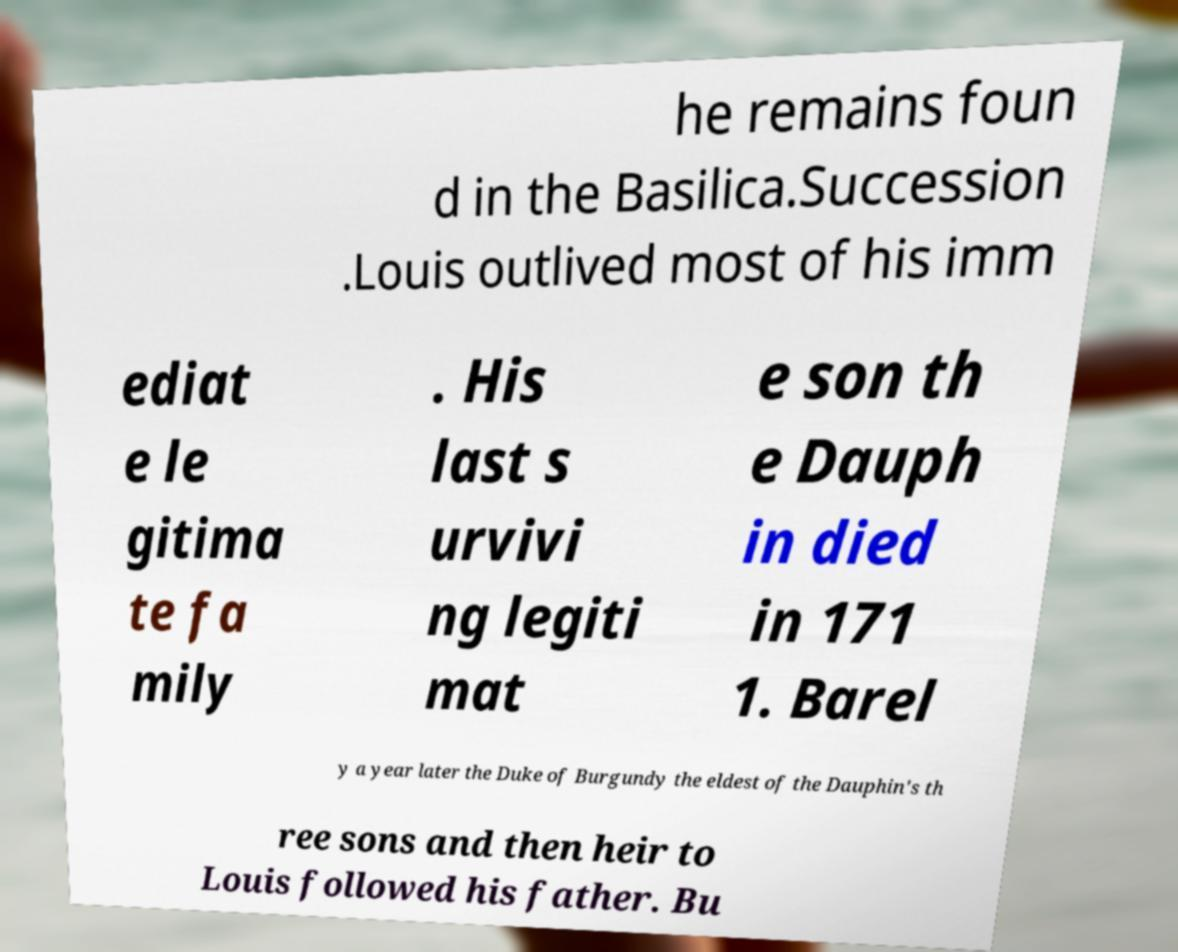For documentation purposes, I need the text within this image transcribed. Could you provide that? he remains foun d in the Basilica.Succession .Louis outlived most of his imm ediat e le gitima te fa mily . His last s urvivi ng legiti mat e son th e Dauph in died in 171 1. Barel y a year later the Duke of Burgundy the eldest of the Dauphin's th ree sons and then heir to Louis followed his father. Bu 